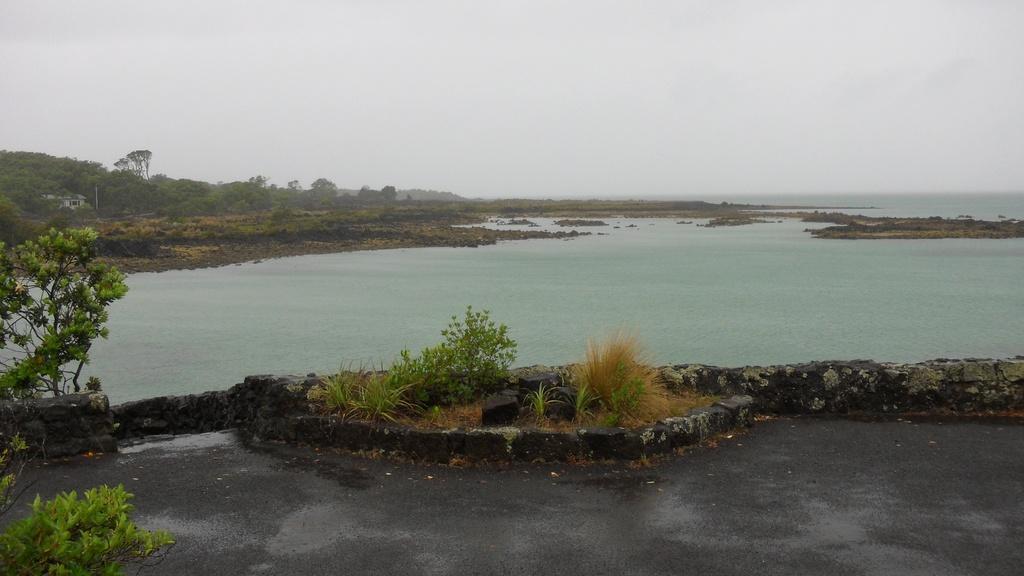How would you summarize this image in a sentence or two? In this image we can see few trees, plants, building, road, water and the sky in the background. 